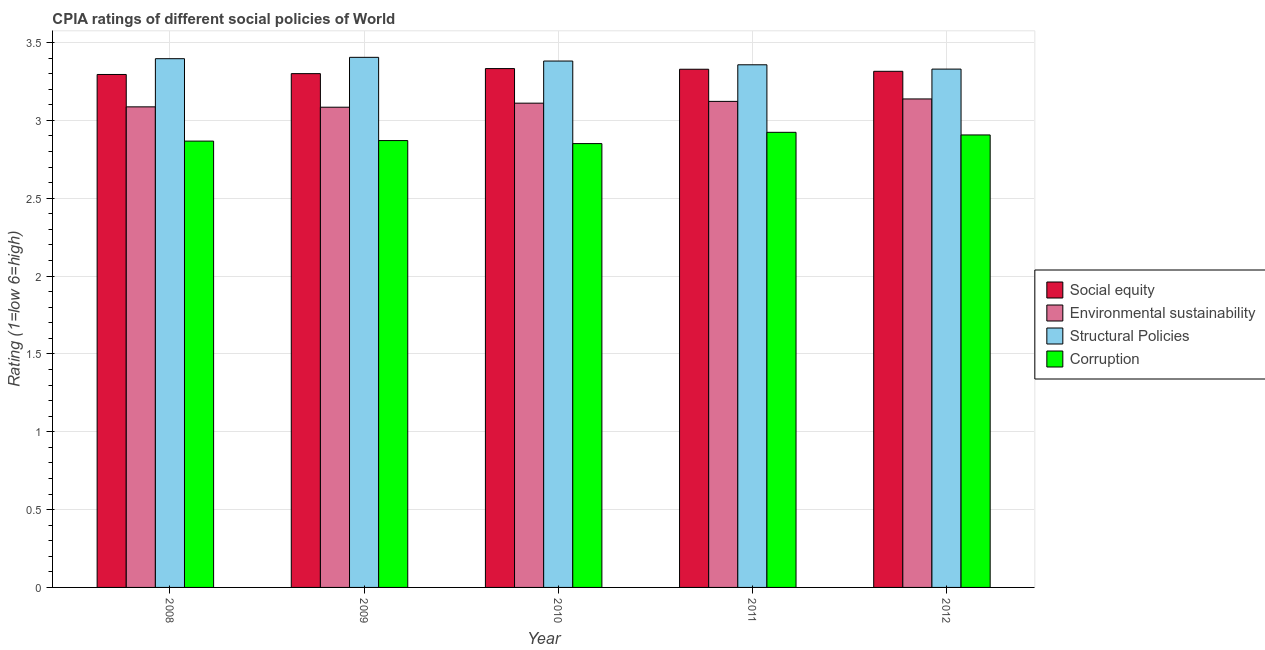How many different coloured bars are there?
Your answer should be very brief. 4. Are the number of bars per tick equal to the number of legend labels?
Provide a short and direct response. Yes. How many bars are there on the 3rd tick from the right?
Ensure brevity in your answer.  4. What is the label of the 3rd group of bars from the left?
Make the answer very short. 2010. In how many cases, is the number of bars for a given year not equal to the number of legend labels?
Your answer should be very brief. 0. What is the cpia rating of structural policies in 2012?
Keep it short and to the point. 3.33. Across all years, what is the maximum cpia rating of environmental sustainability?
Give a very brief answer. 3.14. Across all years, what is the minimum cpia rating of structural policies?
Give a very brief answer. 3.33. What is the total cpia rating of corruption in the graph?
Keep it short and to the point. 14.42. What is the difference between the cpia rating of environmental sustainability in 2008 and that in 2012?
Your answer should be compact. -0.05. What is the difference between the cpia rating of corruption in 2008 and the cpia rating of environmental sustainability in 2009?
Your answer should be compact. -0. What is the average cpia rating of social equity per year?
Offer a very short reply. 3.31. What is the ratio of the cpia rating of structural policies in 2009 to that in 2011?
Your answer should be very brief. 1.01. What is the difference between the highest and the second highest cpia rating of corruption?
Offer a very short reply. 0.02. What is the difference between the highest and the lowest cpia rating of corruption?
Your answer should be very brief. 0.07. What does the 4th bar from the left in 2009 represents?
Ensure brevity in your answer.  Corruption. What does the 4th bar from the right in 2009 represents?
Your answer should be compact. Social equity. Is it the case that in every year, the sum of the cpia rating of social equity and cpia rating of environmental sustainability is greater than the cpia rating of structural policies?
Ensure brevity in your answer.  Yes. Are all the bars in the graph horizontal?
Make the answer very short. No. Does the graph contain any zero values?
Offer a very short reply. No. How many legend labels are there?
Keep it short and to the point. 4. How are the legend labels stacked?
Provide a short and direct response. Vertical. What is the title of the graph?
Your answer should be very brief. CPIA ratings of different social policies of World. What is the Rating (1=low 6=high) of Social equity in 2008?
Your answer should be compact. 3.29. What is the Rating (1=low 6=high) of Environmental sustainability in 2008?
Your answer should be very brief. 3.09. What is the Rating (1=low 6=high) of Structural Policies in 2008?
Keep it short and to the point. 3.4. What is the Rating (1=low 6=high) of Corruption in 2008?
Your answer should be compact. 2.87. What is the Rating (1=low 6=high) of Social equity in 2009?
Provide a succinct answer. 3.3. What is the Rating (1=low 6=high) of Environmental sustainability in 2009?
Provide a short and direct response. 3.08. What is the Rating (1=low 6=high) in Structural Policies in 2009?
Offer a terse response. 3.4. What is the Rating (1=low 6=high) in Corruption in 2009?
Make the answer very short. 2.87. What is the Rating (1=low 6=high) of Social equity in 2010?
Provide a succinct answer. 3.33. What is the Rating (1=low 6=high) in Environmental sustainability in 2010?
Make the answer very short. 3.11. What is the Rating (1=low 6=high) of Structural Policies in 2010?
Ensure brevity in your answer.  3.38. What is the Rating (1=low 6=high) in Corruption in 2010?
Keep it short and to the point. 2.85. What is the Rating (1=low 6=high) of Social equity in 2011?
Provide a succinct answer. 3.33. What is the Rating (1=low 6=high) in Environmental sustainability in 2011?
Your answer should be compact. 3.12. What is the Rating (1=low 6=high) in Structural Policies in 2011?
Give a very brief answer. 3.36. What is the Rating (1=low 6=high) in Corruption in 2011?
Your response must be concise. 2.92. What is the Rating (1=low 6=high) of Social equity in 2012?
Your answer should be compact. 3.31. What is the Rating (1=low 6=high) in Environmental sustainability in 2012?
Offer a terse response. 3.14. What is the Rating (1=low 6=high) in Structural Policies in 2012?
Make the answer very short. 3.33. What is the Rating (1=low 6=high) of Corruption in 2012?
Your answer should be very brief. 2.91. Across all years, what is the maximum Rating (1=low 6=high) of Social equity?
Offer a terse response. 3.33. Across all years, what is the maximum Rating (1=low 6=high) of Environmental sustainability?
Your answer should be compact. 3.14. Across all years, what is the maximum Rating (1=low 6=high) of Structural Policies?
Your answer should be very brief. 3.4. Across all years, what is the maximum Rating (1=low 6=high) of Corruption?
Offer a very short reply. 2.92. Across all years, what is the minimum Rating (1=low 6=high) of Social equity?
Provide a short and direct response. 3.29. Across all years, what is the minimum Rating (1=low 6=high) of Environmental sustainability?
Offer a very short reply. 3.08. Across all years, what is the minimum Rating (1=low 6=high) of Structural Policies?
Give a very brief answer. 3.33. Across all years, what is the minimum Rating (1=low 6=high) of Corruption?
Your response must be concise. 2.85. What is the total Rating (1=low 6=high) of Social equity in the graph?
Offer a very short reply. 16.57. What is the total Rating (1=low 6=high) in Environmental sustainability in the graph?
Your response must be concise. 15.54. What is the total Rating (1=low 6=high) of Structural Policies in the graph?
Ensure brevity in your answer.  16.87. What is the total Rating (1=low 6=high) in Corruption in the graph?
Your answer should be compact. 14.42. What is the difference between the Rating (1=low 6=high) of Social equity in 2008 and that in 2009?
Ensure brevity in your answer.  -0.01. What is the difference between the Rating (1=low 6=high) of Environmental sustainability in 2008 and that in 2009?
Keep it short and to the point. 0. What is the difference between the Rating (1=low 6=high) of Structural Policies in 2008 and that in 2009?
Ensure brevity in your answer.  -0.01. What is the difference between the Rating (1=low 6=high) in Corruption in 2008 and that in 2009?
Ensure brevity in your answer.  -0. What is the difference between the Rating (1=low 6=high) of Social equity in 2008 and that in 2010?
Offer a very short reply. -0.04. What is the difference between the Rating (1=low 6=high) in Environmental sustainability in 2008 and that in 2010?
Offer a terse response. -0.02. What is the difference between the Rating (1=low 6=high) of Structural Policies in 2008 and that in 2010?
Provide a succinct answer. 0.01. What is the difference between the Rating (1=low 6=high) of Corruption in 2008 and that in 2010?
Offer a terse response. 0.02. What is the difference between the Rating (1=low 6=high) in Social equity in 2008 and that in 2011?
Offer a very short reply. -0.03. What is the difference between the Rating (1=low 6=high) of Environmental sustainability in 2008 and that in 2011?
Ensure brevity in your answer.  -0.04. What is the difference between the Rating (1=low 6=high) in Structural Policies in 2008 and that in 2011?
Offer a terse response. 0.04. What is the difference between the Rating (1=low 6=high) of Corruption in 2008 and that in 2011?
Offer a very short reply. -0.06. What is the difference between the Rating (1=low 6=high) in Social equity in 2008 and that in 2012?
Give a very brief answer. -0.02. What is the difference between the Rating (1=low 6=high) of Environmental sustainability in 2008 and that in 2012?
Your answer should be compact. -0.05. What is the difference between the Rating (1=low 6=high) of Structural Policies in 2008 and that in 2012?
Provide a succinct answer. 0.07. What is the difference between the Rating (1=low 6=high) in Corruption in 2008 and that in 2012?
Make the answer very short. -0.04. What is the difference between the Rating (1=low 6=high) in Social equity in 2009 and that in 2010?
Ensure brevity in your answer.  -0.03. What is the difference between the Rating (1=low 6=high) in Environmental sustainability in 2009 and that in 2010?
Provide a succinct answer. -0.03. What is the difference between the Rating (1=low 6=high) in Structural Policies in 2009 and that in 2010?
Offer a very short reply. 0.02. What is the difference between the Rating (1=low 6=high) of Corruption in 2009 and that in 2010?
Your answer should be compact. 0.02. What is the difference between the Rating (1=low 6=high) in Social equity in 2009 and that in 2011?
Your answer should be very brief. -0.03. What is the difference between the Rating (1=low 6=high) in Environmental sustainability in 2009 and that in 2011?
Your answer should be very brief. -0.04. What is the difference between the Rating (1=low 6=high) of Structural Policies in 2009 and that in 2011?
Your answer should be compact. 0.05. What is the difference between the Rating (1=low 6=high) of Corruption in 2009 and that in 2011?
Your response must be concise. -0.05. What is the difference between the Rating (1=low 6=high) of Social equity in 2009 and that in 2012?
Make the answer very short. -0.01. What is the difference between the Rating (1=low 6=high) in Environmental sustainability in 2009 and that in 2012?
Provide a succinct answer. -0.05. What is the difference between the Rating (1=low 6=high) in Structural Policies in 2009 and that in 2012?
Ensure brevity in your answer.  0.08. What is the difference between the Rating (1=low 6=high) of Corruption in 2009 and that in 2012?
Provide a succinct answer. -0.04. What is the difference between the Rating (1=low 6=high) in Social equity in 2010 and that in 2011?
Ensure brevity in your answer.  0. What is the difference between the Rating (1=low 6=high) in Environmental sustainability in 2010 and that in 2011?
Your answer should be very brief. -0.01. What is the difference between the Rating (1=low 6=high) of Structural Policies in 2010 and that in 2011?
Make the answer very short. 0.02. What is the difference between the Rating (1=low 6=high) of Corruption in 2010 and that in 2011?
Provide a succinct answer. -0.07. What is the difference between the Rating (1=low 6=high) of Social equity in 2010 and that in 2012?
Your answer should be very brief. 0.02. What is the difference between the Rating (1=low 6=high) in Environmental sustainability in 2010 and that in 2012?
Offer a very short reply. -0.03. What is the difference between the Rating (1=low 6=high) of Structural Policies in 2010 and that in 2012?
Keep it short and to the point. 0.05. What is the difference between the Rating (1=low 6=high) of Corruption in 2010 and that in 2012?
Offer a terse response. -0.06. What is the difference between the Rating (1=low 6=high) of Social equity in 2011 and that in 2012?
Make the answer very short. 0.01. What is the difference between the Rating (1=low 6=high) of Environmental sustainability in 2011 and that in 2012?
Your response must be concise. -0.02. What is the difference between the Rating (1=low 6=high) of Structural Policies in 2011 and that in 2012?
Your answer should be compact. 0.03. What is the difference between the Rating (1=low 6=high) of Corruption in 2011 and that in 2012?
Provide a short and direct response. 0.02. What is the difference between the Rating (1=low 6=high) of Social equity in 2008 and the Rating (1=low 6=high) of Environmental sustainability in 2009?
Make the answer very short. 0.21. What is the difference between the Rating (1=low 6=high) of Social equity in 2008 and the Rating (1=low 6=high) of Structural Policies in 2009?
Your answer should be very brief. -0.11. What is the difference between the Rating (1=low 6=high) of Social equity in 2008 and the Rating (1=low 6=high) of Corruption in 2009?
Make the answer very short. 0.42. What is the difference between the Rating (1=low 6=high) in Environmental sustainability in 2008 and the Rating (1=low 6=high) in Structural Policies in 2009?
Provide a succinct answer. -0.32. What is the difference between the Rating (1=low 6=high) in Environmental sustainability in 2008 and the Rating (1=low 6=high) in Corruption in 2009?
Your answer should be very brief. 0.22. What is the difference between the Rating (1=low 6=high) in Structural Policies in 2008 and the Rating (1=low 6=high) in Corruption in 2009?
Your response must be concise. 0.53. What is the difference between the Rating (1=low 6=high) of Social equity in 2008 and the Rating (1=low 6=high) of Environmental sustainability in 2010?
Give a very brief answer. 0.18. What is the difference between the Rating (1=low 6=high) in Social equity in 2008 and the Rating (1=low 6=high) in Structural Policies in 2010?
Keep it short and to the point. -0.09. What is the difference between the Rating (1=low 6=high) in Social equity in 2008 and the Rating (1=low 6=high) in Corruption in 2010?
Make the answer very short. 0.44. What is the difference between the Rating (1=low 6=high) in Environmental sustainability in 2008 and the Rating (1=low 6=high) in Structural Policies in 2010?
Your answer should be very brief. -0.29. What is the difference between the Rating (1=low 6=high) in Environmental sustainability in 2008 and the Rating (1=low 6=high) in Corruption in 2010?
Keep it short and to the point. 0.24. What is the difference between the Rating (1=low 6=high) in Structural Policies in 2008 and the Rating (1=low 6=high) in Corruption in 2010?
Make the answer very short. 0.55. What is the difference between the Rating (1=low 6=high) in Social equity in 2008 and the Rating (1=low 6=high) in Environmental sustainability in 2011?
Provide a short and direct response. 0.17. What is the difference between the Rating (1=low 6=high) of Social equity in 2008 and the Rating (1=low 6=high) of Structural Policies in 2011?
Offer a very short reply. -0.06. What is the difference between the Rating (1=low 6=high) of Social equity in 2008 and the Rating (1=low 6=high) of Corruption in 2011?
Your answer should be very brief. 0.37. What is the difference between the Rating (1=low 6=high) of Environmental sustainability in 2008 and the Rating (1=low 6=high) of Structural Policies in 2011?
Keep it short and to the point. -0.27. What is the difference between the Rating (1=low 6=high) of Environmental sustainability in 2008 and the Rating (1=low 6=high) of Corruption in 2011?
Your response must be concise. 0.16. What is the difference between the Rating (1=low 6=high) of Structural Policies in 2008 and the Rating (1=low 6=high) of Corruption in 2011?
Your answer should be very brief. 0.47. What is the difference between the Rating (1=low 6=high) of Social equity in 2008 and the Rating (1=low 6=high) of Environmental sustainability in 2012?
Offer a very short reply. 0.16. What is the difference between the Rating (1=low 6=high) of Social equity in 2008 and the Rating (1=low 6=high) of Structural Policies in 2012?
Your answer should be compact. -0.03. What is the difference between the Rating (1=low 6=high) in Social equity in 2008 and the Rating (1=low 6=high) in Corruption in 2012?
Give a very brief answer. 0.39. What is the difference between the Rating (1=low 6=high) of Environmental sustainability in 2008 and the Rating (1=low 6=high) of Structural Policies in 2012?
Make the answer very short. -0.24. What is the difference between the Rating (1=low 6=high) in Environmental sustainability in 2008 and the Rating (1=low 6=high) in Corruption in 2012?
Your answer should be compact. 0.18. What is the difference between the Rating (1=low 6=high) in Structural Policies in 2008 and the Rating (1=low 6=high) in Corruption in 2012?
Your response must be concise. 0.49. What is the difference between the Rating (1=low 6=high) in Social equity in 2009 and the Rating (1=low 6=high) in Environmental sustainability in 2010?
Your answer should be very brief. 0.19. What is the difference between the Rating (1=low 6=high) in Social equity in 2009 and the Rating (1=low 6=high) in Structural Policies in 2010?
Your answer should be very brief. -0.08. What is the difference between the Rating (1=low 6=high) of Social equity in 2009 and the Rating (1=low 6=high) of Corruption in 2010?
Your answer should be compact. 0.45. What is the difference between the Rating (1=low 6=high) of Environmental sustainability in 2009 and the Rating (1=low 6=high) of Structural Policies in 2010?
Your answer should be compact. -0.3. What is the difference between the Rating (1=low 6=high) in Environmental sustainability in 2009 and the Rating (1=low 6=high) in Corruption in 2010?
Give a very brief answer. 0.23. What is the difference between the Rating (1=low 6=high) in Structural Policies in 2009 and the Rating (1=low 6=high) in Corruption in 2010?
Ensure brevity in your answer.  0.55. What is the difference between the Rating (1=low 6=high) in Social equity in 2009 and the Rating (1=low 6=high) in Environmental sustainability in 2011?
Offer a terse response. 0.18. What is the difference between the Rating (1=low 6=high) in Social equity in 2009 and the Rating (1=low 6=high) in Structural Policies in 2011?
Give a very brief answer. -0.06. What is the difference between the Rating (1=low 6=high) in Social equity in 2009 and the Rating (1=low 6=high) in Corruption in 2011?
Your answer should be compact. 0.38. What is the difference between the Rating (1=low 6=high) of Environmental sustainability in 2009 and the Rating (1=low 6=high) of Structural Policies in 2011?
Offer a terse response. -0.27. What is the difference between the Rating (1=low 6=high) of Environmental sustainability in 2009 and the Rating (1=low 6=high) of Corruption in 2011?
Offer a very short reply. 0.16. What is the difference between the Rating (1=low 6=high) of Structural Policies in 2009 and the Rating (1=low 6=high) of Corruption in 2011?
Your answer should be very brief. 0.48. What is the difference between the Rating (1=low 6=high) of Social equity in 2009 and the Rating (1=low 6=high) of Environmental sustainability in 2012?
Keep it short and to the point. 0.16. What is the difference between the Rating (1=low 6=high) of Social equity in 2009 and the Rating (1=low 6=high) of Structural Policies in 2012?
Offer a very short reply. -0.03. What is the difference between the Rating (1=low 6=high) in Social equity in 2009 and the Rating (1=low 6=high) in Corruption in 2012?
Offer a terse response. 0.39. What is the difference between the Rating (1=low 6=high) of Environmental sustainability in 2009 and the Rating (1=low 6=high) of Structural Policies in 2012?
Offer a terse response. -0.24. What is the difference between the Rating (1=low 6=high) of Environmental sustainability in 2009 and the Rating (1=low 6=high) of Corruption in 2012?
Ensure brevity in your answer.  0.18. What is the difference between the Rating (1=low 6=high) in Structural Policies in 2009 and the Rating (1=low 6=high) in Corruption in 2012?
Make the answer very short. 0.5. What is the difference between the Rating (1=low 6=high) in Social equity in 2010 and the Rating (1=low 6=high) in Environmental sustainability in 2011?
Give a very brief answer. 0.21. What is the difference between the Rating (1=low 6=high) in Social equity in 2010 and the Rating (1=low 6=high) in Structural Policies in 2011?
Your response must be concise. -0.02. What is the difference between the Rating (1=low 6=high) in Social equity in 2010 and the Rating (1=low 6=high) in Corruption in 2011?
Keep it short and to the point. 0.41. What is the difference between the Rating (1=low 6=high) of Environmental sustainability in 2010 and the Rating (1=low 6=high) of Structural Policies in 2011?
Provide a short and direct response. -0.25. What is the difference between the Rating (1=low 6=high) in Environmental sustainability in 2010 and the Rating (1=low 6=high) in Corruption in 2011?
Your answer should be very brief. 0.19. What is the difference between the Rating (1=low 6=high) in Structural Policies in 2010 and the Rating (1=low 6=high) in Corruption in 2011?
Keep it short and to the point. 0.46. What is the difference between the Rating (1=low 6=high) in Social equity in 2010 and the Rating (1=low 6=high) in Environmental sustainability in 2012?
Make the answer very short. 0.2. What is the difference between the Rating (1=low 6=high) in Social equity in 2010 and the Rating (1=low 6=high) in Structural Policies in 2012?
Your answer should be very brief. 0. What is the difference between the Rating (1=low 6=high) in Social equity in 2010 and the Rating (1=low 6=high) in Corruption in 2012?
Offer a terse response. 0.43. What is the difference between the Rating (1=low 6=high) of Environmental sustainability in 2010 and the Rating (1=low 6=high) of Structural Policies in 2012?
Ensure brevity in your answer.  -0.22. What is the difference between the Rating (1=low 6=high) in Environmental sustainability in 2010 and the Rating (1=low 6=high) in Corruption in 2012?
Offer a very short reply. 0.2. What is the difference between the Rating (1=low 6=high) in Structural Policies in 2010 and the Rating (1=low 6=high) in Corruption in 2012?
Your answer should be very brief. 0.47. What is the difference between the Rating (1=low 6=high) of Social equity in 2011 and the Rating (1=low 6=high) of Environmental sustainability in 2012?
Ensure brevity in your answer.  0.19. What is the difference between the Rating (1=low 6=high) of Social equity in 2011 and the Rating (1=low 6=high) of Structural Policies in 2012?
Your response must be concise. -0. What is the difference between the Rating (1=low 6=high) in Social equity in 2011 and the Rating (1=low 6=high) in Corruption in 2012?
Ensure brevity in your answer.  0.42. What is the difference between the Rating (1=low 6=high) of Environmental sustainability in 2011 and the Rating (1=low 6=high) of Structural Policies in 2012?
Provide a short and direct response. -0.21. What is the difference between the Rating (1=low 6=high) in Environmental sustainability in 2011 and the Rating (1=low 6=high) in Corruption in 2012?
Ensure brevity in your answer.  0.22. What is the difference between the Rating (1=low 6=high) of Structural Policies in 2011 and the Rating (1=low 6=high) of Corruption in 2012?
Ensure brevity in your answer.  0.45. What is the average Rating (1=low 6=high) of Social equity per year?
Make the answer very short. 3.31. What is the average Rating (1=low 6=high) of Environmental sustainability per year?
Your response must be concise. 3.11. What is the average Rating (1=low 6=high) of Structural Policies per year?
Make the answer very short. 3.37. What is the average Rating (1=low 6=high) in Corruption per year?
Keep it short and to the point. 2.88. In the year 2008, what is the difference between the Rating (1=low 6=high) of Social equity and Rating (1=low 6=high) of Environmental sustainability?
Your answer should be very brief. 0.21. In the year 2008, what is the difference between the Rating (1=low 6=high) of Social equity and Rating (1=low 6=high) of Structural Policies?
Ensure brevity in your answer.  -0.1. In the year 2008, what is the difference between the Rating (1=low 6=high) of Social equity and Rating (1=low 6=high) of Corruption?
Provide a succinct answer. 0.43. In the year 2008, what is the difference between the Rating (1=low 6=high) of Environmental sustainability and Rating (1=low 6=high) of Structural Policies?
Make the answer very short. -0.31. In the year 2008, what is the difference between the Rating (1=low 6=high) of Environmental sustainability and Rating (1=low 6=high) of Corruption?
Your answer should be very brief. 0.22. In the year 2008, what is the difference between the Rating (1=low 6=high) in Structural Policies and Rating (1=low 6=high) in Corruption?
Your answer should be compact. 0.53. In the year 2009, what is the difference between the Rating (1=low 6=high) in Social equity and Rating (1=low 6=high) in Environmental sustainability?
Your answer should be compact. 0.22. In the year 2009, what is the difference between the Rating (1=low 6=high) in Social equity and Rating (1=low 6=high) in Structural Policies?
Give a very brief answer. -0.1. In the year 2009, what is the difference between the Rating (1=low 6=high) in Social equity and Rating (1=low 6=high) in Corruption?
Provide a succinct answer. 0.43. In the year 2009, what is the difference between the Rating (1=low 6=high) in Environmental sustainability and Rating (1=low 6=high) in Structural Policies?
Make the answer very short. -0.32. In the year 2009, what is the difference between the Rating (1=low 6=high) of Environmental sustainability and Rating (1=low 6=high) of Corruption?
Provide a succinct answer. 0.21. In the year 2009, what is the difference between the Rating (1=low 6=high) of Structural Policies and Rating (1=low 6=high) of Corruption?
Provide a short and direct response. 0.53. In the year 2010, what is the difference between the Rating (1=low 6=high) of Social equity and Rating (1=low 6=high) of Environmental sustainability?
Make the answer very short. 0.22. In the year 2010, what is the difference between the Rating (1=low 6=high) of Social equity and Rating (1=low 6=high) of Structural Policies?
Provide a short and direct response. -0.05. In the year 2010, what is the difference between the Rating (1=low 6=high) of Social equity and Rating (1=low 6=high) of Corruption?
Your answer should be very brief. 0.48. In the year 2010, what is the difference between the Rating (1=low 6=high) of Environmental sustainability and Rating (1=low 6=high) of Structural Policies?
Give a very brief answer. -0.27. In the year 2010, what is the difference between the Rating (1=low 6=high) of Environmental sustainability and Rating (1=low 6=high) of Corruption?
Your answer should be very brief. 0.26. In the year 2010, what is the difference between the Rating (1=low 6=high) in Structural Policies and Rating (1=low 6=high) in Corruption?
Offer a very short reply. 0.53. In the year 2011, what is the difference between the Rating (1=low 6=high) in Social equity and Rating (1=low 6=high) in Environmental sustainability?
Offer a very short reply. 0.21. In the year 2011, what is the difference between the Rating (1=low 6=high) in Social equity and Rating (1=low 6=high) in Structural Policies?
Keep it short and to the point. -0.03. In the year 2011, what is the difference between the Rating (1=low 6=high) of Social equity and Rating (1=low 6=high) of Corruption?
Offer a very short reply. 0.41. In the year 2011, what is the difference between the Rating (1=low 6=high) of Environmental sustainability and Rating (1=low 6=high) of Structural Policies?
Your answer should be very brief. -0.23. In the year 2011, what is the difference between the Rating (1=low 6=high) in Environmental sustainability and Rating (1=low 6=high) in Corruption?
Keep it short and to the point. 0.2. In the year 2011, what is the difference between the Rating (1=low 6=high) of Structural Policies and Rating (1=low 6=high) of Corruption?
Offer a terse response. 0.43. In the year 2012, what is the difference between the Rating (1=low 6=high) of Social equity and Rating (1=low 6=high) of Environmental sustainability?
Ensure brevity in your answer.  0.18. In the year 2012, what is the difference between the Rating (1=low 6=high) in Social equity and Rating (1=low 6=high) in Structural Policies?
Offer a very short reply. -0.01. In the year 2012, what is the difference between the Rating (1=low 6=high) in Social equity and Rating (1=low 6=high) in Corruption?
Provide a short and direct response. 0.41. In the year 2012, what is the difference between the Rating (1=low 6=high) of Environmental sustainability and Rating (1=low 6=high) of Structural Policies?
Keep it short and to the point. -0.19. In the year 2012, what is the difference between the Rating (1=low 6=high) in Environmental sustainability and Rating (1=low 6=high) in Corruption?
Your response must be concise. 0.23. In the year 2012, what is the difference between the Rating (1=low 6=high) of Structural Policies and Rating (1=low 6=high) of Corruption?
Provide a short and direct response. 0.42. What is the ratio of the Rating (1=low 6=high) of Social equity in 2008 to that in 2009?
Ensure brevity in your answer.  1. What is the ratio of the Rating (1=low 6=high) of Structural Policies in 2008 to that in 2009?
Your response must be concise. 1. What is the ratio of the Rating (1=low 6=high) of Social equity in 2008 to that in 2010?
Make the answer very short. 0.99. What is the ratio of the Rating (1=low 6=high) in Structural Policies in 2008 to that in 2010?
Ensure brevity in your answer.  1. What is the ratio of the Rating (1=low 6=high) of Corruption in 2008 to that in 2010?
Your response must be concise. 1.01. What is the ratio of the Rating (1=low 6=high) of Social equity in 2008 to that in 2011?
Provide a succinct answer. 0.99. What is the ratio of the Rating (1=low 6=high) of Environmental sustainability in 2008 to that in 2011?
Offer a very short reply. 0.99. What is the ratio of the Rating (1=low 6=high) of Structural Policies in 2008 to that in 2011?
Ensure brevity in your answer.  1.01. What is the ratio of the Rating (1=low 6=high) in Corruption in 2008 to that in 2011?
Your answer should be very brief. 0.98. What is the ratio of the Rating (1=low 6=high) in Social equity in 2008 to that in 2012?
Your answer should be very brief. 0.99. What is the ratio of the Rating (1=low 6=high) in Environmental sustainability in 2008 to that in 2012?
Your answer should be compact. 0.98. What is the ratio of the Rating (1=low 6=high) in Structural Policies in 2008 to that in 2012?
Offer a very short reply. 1.02. What is the ratio of the Rating (1=low 6=high) in Corruption in 2008 to that in 2012?
Give a very brief answer. 0.99. What is the ratio of the Rating (1=low 6=high) of Social equity in 2009 to that in 2010?
Offer a terse response. 0.99. What is the ratio of the Rating (1=low 6=high) of Corruption in 2009 to that in 2010?
Make the answer very short. 1.01. What is the ratio of the Rating (1=low 6=high) of Social equity in 2009 to that in 2011?
Your answer should be very brief. 0.99. What is the ratio of the Rating (1=low 6=high) in Structural Policies in 2009 to that in 2011?
Your answer should be compact. 1.01. What is the ratio of the Rating (1=low 6=high) in Corruption in 2009 to that in 2011?
Give a very brief answer. 0.98. What is the ratio of the Rating (1=low 6=high) of Environmental sustainability in 2009 to that in 2012?
Your response must be concise. 0.98. What is the ratio of the Rating (1=low 6=high) in Structural Policies in 2009 to that in 2012?
Give a very brief answer. 1.02. What is the ratio of the Rating (1=low 6=high) of Corruption in 2009 to that in 2012?
Give a very brief answer. 0.99. What is the ratio of the Rating (1=low 6=high) of Social equity in 2010 to that in 2011?
Your response must be concise. 1. What is the ratio of the Rating (1=low 6=high) of Environmental sustainability in 2010 to that in 2011?
Provide a succinct answer. 1. What is the ratio of the Rating (1=low 6=high) in Structural Policies in 2010 to that in 2011?
Your answer should be very brief. 1.01. What is the ratio of the Rating (1=low 6=high) in Corruption in 2010 to that in 2011?
Give a very brief answer. 0.98. What is the ratio of the Rating (1=low 6=high) of Structural Policies in 2010 to that in 2012?
Your answer should be compact. 1.02. What is the ratio of the Rating (1=low 6=high) in Corruption in 2010 to that in 2012?
Offer a very short reply. 0.98. What is the ratio of the Rating (1=low 6=high) of Social equity in 2011 to that in 2012?
Ensure brevity in your answer.  1. What is the ratio of the Rating (1=low 6=high) of Structural Policies in 2011 to that in 2012?
Give a very brief answer. 1.01. What is the ratio of the Rating (1=low 6=high) of Corruption in 2011 to that in 2012?
Provide a succinct answer. 1.01. What is the difference between the highest and the second highest Rating (1=low 6=high) in Social equity?
Provide a short and direct response. 0. What is the difference between the highest and the second highest Rating (1=low 6=high) of Environmental sustainability?
Provide a short and direct response. 0.02. What is the difference between the highest and the second highest Rating (1=low 6=high) in Structural Policies?
Make the answer very short. 0.01. What is the difference between the highest and the second highest Rating (1=low 6=high) in Corruption?
Give a very brief answer. 0.02. What is the difference between the highest and the lowest Rating (1=low 6=high) of Social equity?
Your answer should be very brief. 0.04. What is the difference between the highest and the lowest Rating (1=low 6=high) in Environmental sustainability?
Provide a succinct answer. 0.05. What is the difference between the highest and the lowest Rating (1=low 6=high) of Structural Policies?
Provide a short and direct response. 0.08. What is the difference between the highest and the lowest Rating (1=low 6=high) in Corruption?
Give a very brief answer. 0.07. 